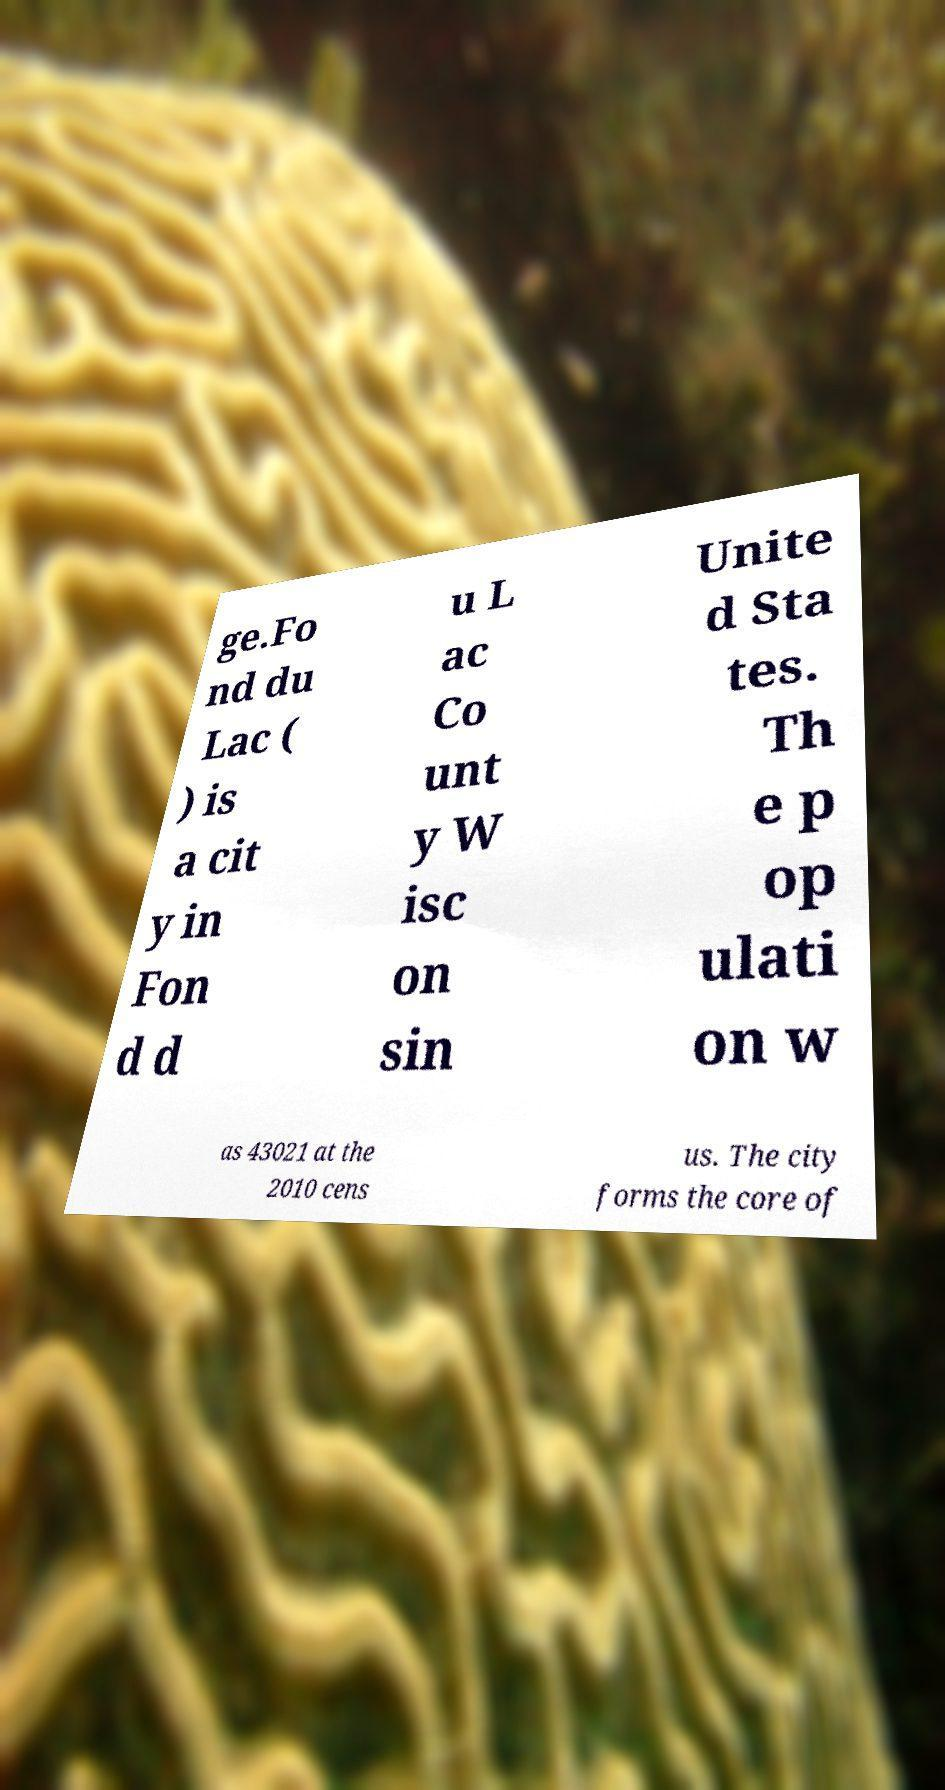Please identify and transcribe the text found in this image. ge.Fo nd du Lac ( ) is a cit y in Fon d d u L ac Co unt y W isc on sin Unite d Sta tes. Th e p op ulati on w as 43021 at the 2010 cens us. The city forms the core of 